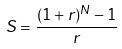<formula> <loc_0><loc_0><loc_500><loc_500>S = \frac { ( 1 + r ) ^ { N } - 1 } { r }</formula> 